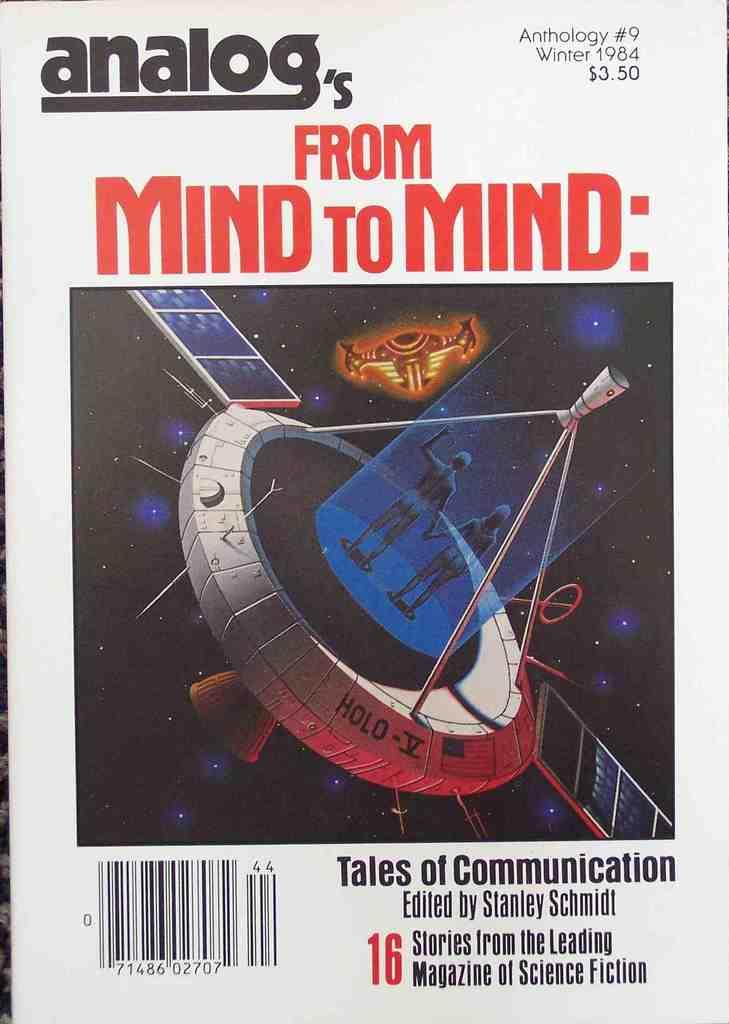What kind of tales are these?
Offer a very short reply. Communication. Who is the author of the book?
Give a very brief answer. Stanley schmidt. 